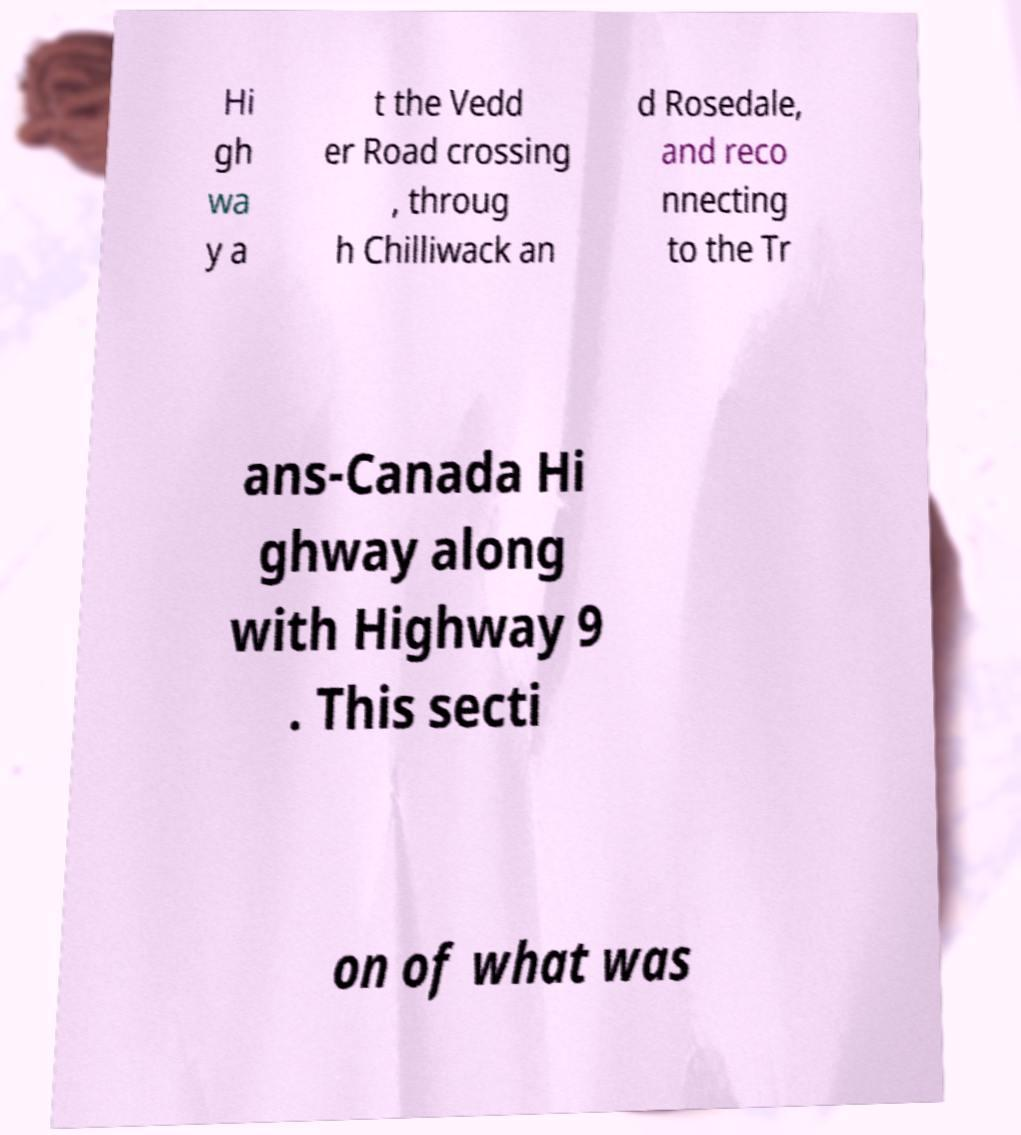For documentation purposes, I need the text within this image transcribed. Could you provide that? Hi gh wa y a t the Vedd er Road crossing , throug h Chilliwack an d Rosedale, and reco nnecting to the Tr ans-Canada Hi ghway along with Highway 9 . This secti on of what was 